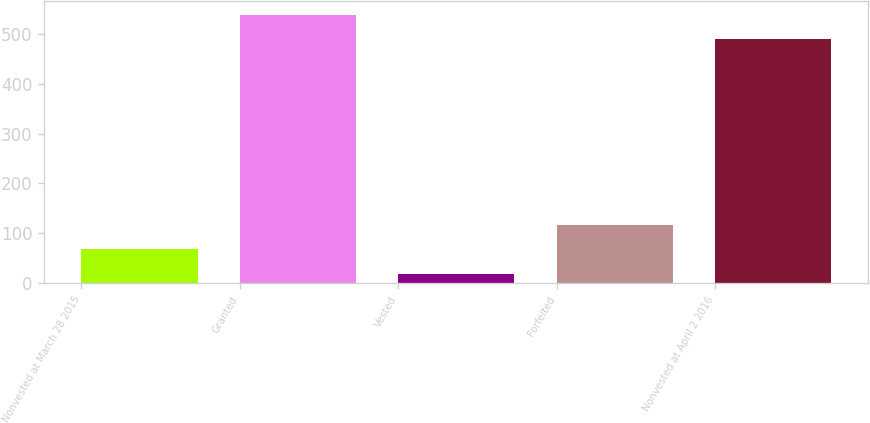Convert chart. <chart><loc_0><loc_0><loc_500><loc_500><bar_chart><fcel>Nonvested at March 28 2015<fcel>Granted<fcel>Vested<fcel>Forfeited<fcel>Nonvested at April 2 2016<nl><fcel>67<fcel>539<fcel>18<fcel>116<fcel>490<nl></chart> 